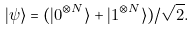Convert formula to latex. <formula><loc_0><loc_0><loc_500><loc_500>| \psi \rangle = ( | 0 ^ { \otimes N } \rangle + | 1 ^ { \otimes N } \rangle ) / \sqrt { 2 } .</formula> 